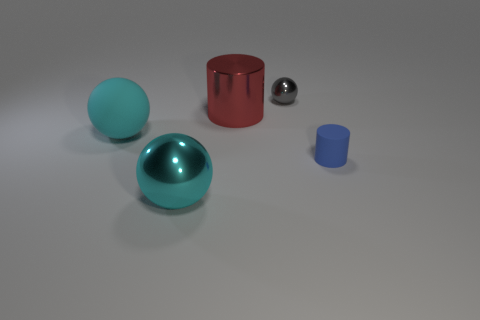Subtract all gray balls. How many balls are left? 2 Subtract all red cylinders. How many cylinders are left? 1 Subtract all cylinders. How many objects are left? 3 Add 3 big red metal cylinders. How many objects exist? 8 Subtract all purple cylinders. How many red balls are left? 0 Add 3 big red objects. How many big red objects are left? 4 Add 3 cyan things. How many cyan things exist? 5 Subtract 0 purple cylinders. How many objects are left? 5 Subtract 2 spheres. How many spheres are left? 1 Subtract all yellow cylinders. Subtract all blue balls. How many cylinders are left? 2 